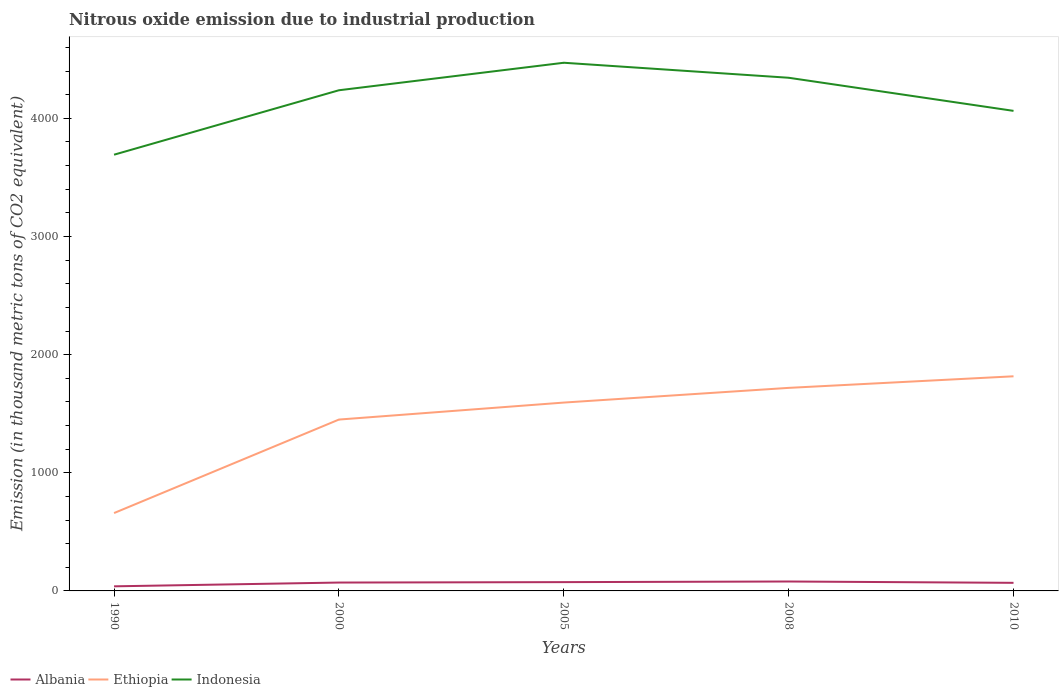Does the line corresponding to Indonesia intersect with the line corresponding to Ethiopia?
Offer a very short reply. No. Is the number of lines equal to the number of legend labels?
Offer a very short reply. Yes. Across all years, what is the maximum amount of nitrous oxide emitted in Albania?
Offer a terse response. 38.9. What is the total amount of nitrous oxide emitted in Albania in the graph?
Provide a short and direct response. -40.9. What is the difference between the highest and the second highest amount of nitrous oxide emitted in Albania?
Keep it short and to the point. 40.9. What is the difference between the highest and the lowest amount of nitrous oxide emitted in Ethiopia?
Your answer should be compact. 4. How many lines are there?
Provide a short and direct response. 3. Are the values on the major ticks of Y-axis written in scientific E-notation?
Your response must be concise. No. Where does the legend appear in the graph?
Your answer should be compact. Bottom left. How are the legend labels stacked?
Give a very brief answer. Horizontal. What is the title of the graph?
Offer a very short reply. Nitrous oxide emission due to industrial production. Does "Hong Kong" appear as one of the legend labels in the graph?
Offer a very short reply. No. What is the label or title of the X-axis?
Make the answer very short. Years. What is the label or title of the Y-axis?
Offer a terse response. Emission (in thousand metric tons of CO2 equivalent). What is the Emission (in thousand metric tons of CO2 equivalent) in Albania in 1990?
Give a very brief answer. 38.9. What is the Emission (in thousand metric tons of CO2 equivalent) of Ethiopia in 1990?
Keep it short and to the point. 659.1. What is the Emission (in thousand metric tons of CO2 equivalent) in Indonesia in 1990?
Your answer should be very brief. 3692.4. What is the Emission (in thousand metric tons of CO2 equivalent) in Albania in 2000?
Your answer should be very brief. 70.9. What is the Emission (in thousand metric tons of CO2 equivalent) in Ethiopia in 2000?
Give a very brief answer. 1450.5. What is the Emission (in thousand metric tons of CO2 equivalent) of Indonesia in 2000?
Offer a very short reply. 4237.9. What is the Emission (in thousand metric tons of CO2 equivalent) in Albania in 2005?
Your response must be concise. 74.5. What is the Emission (in thousand metric tons of CO2 equivalent) of Ethiopia in 2005?
Provide a short and direct response. 1594.3. What is the Emission (in thousand metric tons of CO2 equivalent) of Indonesia in 2005?
Offer a very short reply. 4470.7. What is the Emission (in thousand metric tons of CO2 equivalent) in Albania in 2008?
Your response must be concise. 79.8. What is the Emission (in thousand metric tons of CO2 equivalent) in Ethiopia in 2008?
Give a very brief answer. 1718.7. What is the Emission (in thousand metric tons of CO2 equivalent) in Indonesia in 2008?
Provide a short and direct response. 4343.7. What is the Emission (in thousand metric tons of CO2 equivalent) in Albania in 2010?
Your answer should be compact. 68.5. What is the Emission (in thousand metric tons of CO2 equivalent) in Ethiopia in 2010?
Keep it short and to the point. 1816.7. What is the Emission (in thousand metric tons of CO2 equivalent) of Indonesia in 2010?
Provide a succinct answer. 4063.4. Across all years, what is the maximum Emission (in thousand metric tons of CO2 equivalent) in Albania?
Your answer should be very brief. 79.8. Across all years, what is the maximum Emission (in thousand metric tons of CO2 equivalent) of Ethiopia?
Give a very brief answer. 1816.7. Across all years, what is the maximum Emission (in thousand metric tons of CO2 equivalent) in Indonesia?
Offer a terse response. 4470.7. Across all years, what is the minimum Emission (in thousand metric tons of CO2 equivalent) in Albania?
Your answer should be very brief. 38.9. Across all years, what is the minimum Emission (in thousand metric tons of CO2 equivalent) of Ethiopia?
Your answer should be very brief. 659.1. Across all years, what is the minimum Emission (in thousand metric tons of CO2 equivalent) in Indonesia?
Your answer should be compact. 3692.4. What is the total Emission (in thousand metric tons of CO2 equivalent) of Albania in the graph?
Offer a terse response. 332.6. What is the total Emission (in thousand metric tons of CO2 equivalent) of Ethiopia in the graph?
Keep it short and to the point. 7239.3. What is the total Emission (in thousand metric tons of CO2 equivalent) of Indonesia in the graph?
Keep it short and to the point. 2.08e+04. What is the difference between the Emission (in thousand metric tons of CO2 equivalent) of Albania in 1990 and that in 2000?
Make the answer very short. -32. What is the difference between the Emission (in thousand metric tons of CO2 equivalent) of Ethiopia in 1990 and that in 2000?
Ensure brevity in your answer.  -791.4. What is the difference between the Emission (in thousand metric tons of CO2 equivalent) in Indonesia in 1990 and that in 2000?
Offer a very short reply. -545.5. What is the difference between the Emission (in thousand metric tons of CO2 equivalent) of Albania in 1990 and that in 2005?
Provide a short and direct response. -35.6. What is the difference between the Emission (in thousand metric tons of CO2 equivalent) of Ethiopia in 1990 and that in 2005?
Make the answer very short. -935.2. What is the difference between the Emission (in thousand metric tons of CO2 equivalent) in Indonesia in 1990 and that in 2005?
Offer a very short reply. -778.3. What is the difference between the Emission (in thousand metric tons of CO2 equivalent) in Albania in 1990 and that in 2008?
Provide a succinct answer. -40.9. What is the difference between the Emission (in thousand metric tons of CO2 equivalent) of Ethiopia in 1990 and that in 2008?
Give a very brief answer. -1059.6. What is the difference between the Emission (in thousand metric tons of CO2 equivalent) of Indonesia in 1990 and that in 2008?
Ensure brevity in your answer.  -651.3. What is the difference between the Emission (in thousand metric tons of CO2 equivalent) of Albania in 1990 and that in 2010?
Provide a succinct answer. -29.6. What is the difference between the Emission (in thousand metric tons of CO2 equivalent) of Ethiopia in 1990 and that in 2010?
Give a very brief answer. -1157.6. What is the difference between the Emission (in thousand metric tons of CO2 equivalent) of Indonesia in 1990 and that in 2010?
Keep it short and to the point. -371. What is the difference between the Emission (in thousand metric tons of CO2 equivalent) of Albania in 2000 and that in 2005?
Provide a short and direct response. -3.6. What is the difference between the Emission (in thousand metric tons of CO2 equivalent) of Ethiopia in 2000 and that in 2005?
Give a very brief answer. -143.8. What is the difference between the Emission (in thousand metric tons of CO2 equivalent) in Indonesia in 2000 and that in 2005?
Provide a succinct answer. -232.8. What is the difference between the Emission (in thousand metric tons of CO2 equivalent) of Albania in 2000 and that in 2008?
Your answer should be compact. -8.9. What is the difference between the Emission (in thousand metric tons of CO2 equivalent) in Ethiopia in 2000 and that in 2008?
Ensure brevity in your answer.  -268.2. What is the difference between the Emission (in thousand metric tons of CO2 equivalent) of Indonesia in 2000 and that in 2008?
Offer a very short reply. -105.8. What is the difference between the Emission (in thousand metric tons of CO2 equivalent) in Ethiopia in 2000 and that in 2010?
Offer a terse response. -366.2. What is the difference between the Emission (in thousand metric tons of CO2 equivalent) of Indonesia in 2000 and that in 2010?
Give a very brief answer. 174.5. What is the difference between the Emission (in thousand metric tons of CO2 equivalent) in Albania in 2005 and that in 2008?
Your answer should be very brief. -5.3. What is the difference between the Emission (in thousand metric tons of CO2 equivalent) of Ethiopia in 2005 and that in 2008?
Keep it short and to the point. -124.4. What is the difference between the Emission (in thousand metric tons of CO2 equivalent) of Indonesia in 2005 and that in 2008?
Ensure brevity in your answer.  127. What is the difference between the Emission (in thousand metric tons of CO2 equivalent) of Albania in 2005 and that in 2010?
Provide a short and direct response. 6. What is the difference between the Emission (in thousand metric tons of CO2 equivalent) of Ethiopia in 2005 and that in 2010?
Offer a terse response. -222.4. What is the difference between the Emission (in thousand metric tons of CO2 equivalent) of Indonesia in 2005 and that in 2010?
Keep it short and to the point. 407.3. What is the difference between the Emission (in thousand metric tons of CO2 equivalent) of Albania in 2008 and that in 2010?
Offer a terse response. 11.3. What is the difference between the Emission (in thousand metric tons of CO2 equivalent) in Ethiopia in 2008 and that in 2010?
Keep it short and to the point. -98. What is the difference between the Emission (in thousand metric tons of CO2 equivalent) of Indonesia in 2008 and that in 2010?
Provide a succinct answer. 280.3. What is the difference between the Emission (in thousand metric tons of CO2 equivalent) in Albania in 1990 and the Emission (in thousand metric tons of CO2 equivalent) in Ethiopia in 2000?
Your response must be concise. -1411.6. What is the difference between the Emission (in thousand metric tons of CO2 equivalent) in Albania in 1990 and the Emission (in thousand metric tons of CO2 equivalent) in Indonesia in 2000?
Your answer should be compact. -4199. What is the difference between the Emission (in thousand metric tons of CO2 equivalent) in Ethiopia in 1990 and the Emission (in thousand metric tons of CO2 equivalent) in Indonesia in 2000?
Provide a succinct answer. -3578.8. What is the difference between the Emission (in thousand metric tons of CO2 equivalent) of Albania in 1990 and the Emission (in thousand metric tons of CO2 equivalent) of Ethiopia in 2005?
Offer a terse response. -1555.4. What is the difference between the Emission (in thousand metric tons of CO2 equivalent) in Albania in 1990 and the Emission (in thousand metric tons of CO2 equivalent) in Indonesia in 2005?
Make the answer very short. -4431.8. What is the difference between the Emission (in thousand metric tons of CO2 equivalent) of Ethiopia in 1990 and the Emission (in thousand metric tons of CO2 equivalent) of Indonesia in 2005?
Your answer should be compact. -3811.6. What is the difference between the Emission (in thousand metric tons of CO2 equivalent) in Albania in 1990 and the Emission (in thousand metric tons of CO2 equivalent) in Ethiopia in 2008?
Provide a short and direct response. -1679.8. What is the difference between the Emission (in thousand metric tons of CO2 equivalent) in Albania in 1990 and the Emission (in thousand metric tons of CO2 equivalent) in Indonesia in 2008?
Provide a succinct answer. -4304.8. What is the difference between the Emission (in thousand metric tons of CO2 equivalent) of Ethiopia in 1990 and the Emission (in thousand metric tons of CO2 equivalent) of Indonesia in 2008?
Ensure brevity in your answer.  -3684.6. What is the difference between the Emission (in thousand metric tons of CO2 equivalent) of Albania in 1990 and the Emission (in thousand metric tons of CO2 equivalent) of Ethiopia in 2010?
Your answer should be very brief. -1777.8. What is the difference between the Emission (in thousand metric tons of CO2 equivalent) of Albania in 1990 and the Emission (in thousand metric tons of CO2 equivalent) of Indonesia in 2010?
Provide a succinct answer. -4024.5. What is the difference between the Emission (in thousand metric tons of CO2 equivalent) in Ethiopia in 1990 and the Emission (in thousand metric tons of CO2 equivalent) in Indonesia in 2010?
Make the answer very short. -3404.3. What is the difference between the Emission (in thousand metric tons of CO2 equivalent) in Albania in 2000 and the Emission (in thousand metric tons of CO2 equivalent) in Ethiopia in 2005?
Provide a short and direct response. -1523.4. What is the difference between the Emission (in thousand metric tons of CO2 equivalent) in Albania in 2000 and the Emission (in thousand metric tons of CO2 equivalent) in Indonesia in 2005?
Ensure brevity in your answer.  -4399.8. What is the difference between the Emission (in thousand metric tons of CO2 equivalent) in Ethiopia in 2000 and the Emission (in thousand metric tons of CO2 equivalent) in Indonesia in 2005?
Your answer should be compact. -3020.2. What is the difference between the Emission (in thousand metric tons of CO2 equivalent) in Albania in 2000 and the Emission (in thousand metric tons of CO2 equivalent) in Ethiopia in 2008?
Offer a terse response. -1647.8. What is the difference between the Emission (in thousand metric tons of CO2 equivalent) in Albania in 2000 and the Emission (in thousand metric tons of CO2 equivalent) in Indonesia in 2008?
Ensure brevity in your answer.  -4272.8. What is the difference between the Emission (in thousand metric tons of CO2 equivalent) in Ethiopia in 2000 and the Emission (in thousand metric tons of CO2 equivalent) in Indonesia in 2008?
Your response must be concise. -2893.2. What is the difference between the Emission (in thousand metric tons of CO2 equivalent) of Albania in 2000 and the Emission (in thousand metric tons of CO2 equivalent) of Ethiopia in 2010?
Your answer should be compact. -1745.8. What is the difference between the Emission (in thousand metric tons of CO2 equivalent) in Albania in 2000 and the Emission (in thousand metric tons of CO2 equivalent) in Indonesia in 2010?
Your response must be concise. -3992.5. What is the difference between the Emission (in thousand metric tons of CO2 equivalent) in Ethiopia in 2000 and the Emission (in thousand metric tons of CO2 equivalent) in Indonesia in 2010?
Ensure brevity in your answer.  -2612.9. What is the difference between the Emission (in thousand metric tons of CO2 equivalent) of Albania in 2005 and the Emission (in thousand metric tons of CO2 equivalent) of Ethiopia in 2008?
Give a very brief answer. -1644.2. What is the difference between the Emission (in thousand metric tons of CO2 equivalent) in Albania in 2005 and the Emission (in thousand metric tons of CO2 equivalent) in Indonesia in 2008?
Give a very brief answer. -4269.2. What is the difference between the Emission (in thousand metric tons of CO2 equivalent) of Ethiopia in 2005 and the Emission (in thousand metric tons of CO2 equivalent) of Indonesia in 2008?
Offer a very short reply. -2749.4. What is the difference between the Emission (in thousand metric tons of CO2 equivalent) of Albania in 2005 and the Emission (in thousand metric tons of CO2 equivalent) of Ethiopia in 2010?
Provide a short and direct response. -1742.2. What is the difference between the Emission (in thousand metric tons of CO2 equivalent) in Albania in 2005 and the Emission (in thousand metric tons of CO2 equivalent) in Indonesia in 2010?
Offer a terse response. -3988.9. What is the difference between the Emission (in thousand metric tons of CO2 equivalent) in Ethiopia in 2005 and the Emission (in thousand metric tons of CO2 equivalent) in Indonesia in 2010?
Provide a succinct answer. -2469.1. What is the difference between the Emission (in thousand metric tons of CO2 equivalent) of Albania in 2008 and the Emission (in thousand metric tons of CO2 equivalent) of Ethiopia in 2010?
Ensure brevity in your answer.  -1736.9. What is the difference between the Emission (in thousand metric tons of CO2 equivalent) of Albania in 2008 and the Emission (in thousand metric tons of CO2 equivalent) of Indonesia in 2010?
Your answer should be compact. -3983.6. What is the difference between the Emission (in thousand metric tons of CO2 equivalent) in Ethiopia in 2008 and the Emission (in thousand metric tons of CO2 equivalent) in Indonesia in 2010?
Keep it short and to the point. -2344.7. What is the average Emission (in thousand metric tons of CO2 equivalent) in Albania per year?
Your answer should be very brief. 66.52. What is the average Emission (in thousand metric tons of CO2 equivalent) of Ethiopia per year?
Provide a short and direct response. 1447.86. What is the average Emission (in thousand metric tons of CO2 equivalent) in Indonesia per year?
Your answer should be very brief. 4161.62. In the year 1990, what is the difference between the Emission (in thousand metric tons of CO2 equivalent) of Albania and Emission (in thousand metric tons of CO2 equivalent) of Ethiopia?
Ensure brevity in your answer.  -620.2. In the year 1990, what is the difference between the Emission (in thousand metric tons of CO2 equivalent) in Albania and Emission (in thousand metric tons of CO2 equivalent) in Indonesia?
Make the answer very short. -3653.5. In the year 1990, what is the difference between the Emission (in thousand metric tons of CO2 equivalent) in Ethiopia and Emission (in thousand metric tons of CO2 equivalent) in Indonesia?
Ensure brevity in your answer.  -3033.3. In the year 2000, what is the difference between the Emission (in thousand metric tons of CO2 equivalent) in Albania and Emission (in thousand metric tons of CO2 equivalent) in Ethiopia?
Provide a short and direct response. -1379.6. In the year 2000, what is the difference between the Emission (in thousand metric tons of CO2 equivalent) of Albania and Emission (in thousand metric tons of CO2 equivalent) of Indonesia?
Offer a terse response. -4167. In the year 2000, what is the difference between the Emission (in thousand metric tons of CO2 equivalent) in Ethiopia and Emission (in thousand metric tons of CO2 equivalent) in Indonesia?
Provide a short and direct response. -2787.4. In the year 2005, what is the difference between the Emission (in thousand metric tons of CO2 equivalent) in Albania and Emission (in thousand metric tons of CO2 equivalent) in Ethiopia?
Your answer should be very brief. -1519.8. In the year 2005, what is the difference between the Emission (in thousand metric tons of CO2 equivalent) in Albania and Emission (in thousand metric tons of CO2 equivalent) in Indonesia?
Make the answer very short. -4396.2. In the year 2005, what is the difference between the Emission (in thousand metric tons of CO2 equivalent) of Ethiopia and Emission (in thousand metric tons of CO2 equivalent) of Indonesia?
Offer a very short reply. -2876.4. In the year 2008, what is the difference between the Emission (in thousand metric tons of CO2 equivalent) in Albania and Emission (in thousand metric tons of CO2 equivalent) in Ethiopia?
Keep it short and to the point. -1638.9. In the year 2008, what is the difference between the Emission (in thousand metric tons of CO2 equivalent) in Albania and Emission (in thousand metric tons of CO2 equivalent) in Indonesia?
Your answer should be very brief. -4263.9. In the year 2008, what is the difference between the Emission (in thousand metric tons of CO2 equivalent) in Ethiopia and Emission (in thousand metric tons of CO2 equivalent) in Indonesia?
Ensure brevity in your answer.  -2625. In the year 2010, what is the difference between the Emission (in thousand metric tons of CO2 equivalent) of Albania and Emission (in thousand metric tons of CO2 equivalent) of Ethiopia?
Give a very brief answer. -1748.2. In the year 2010, what is the difference between the Emission (in thousand metric tons of CO2 equivalent) of Albania and Emission (in thousand metric tons of CO2 equivalent) of Indonesia?
Keep it short and to the point. -3994.9. In the year 2010, what is the difference between the Emission (in thousand metric tons of CO2 equivalent) of Ethiopia and Emission (in thousand metric tons of CO2 equivalent) of Indonesia?
Give a very brief answer. -2246.7. What is the ratio of the Emission (in thousand metric tons of CO2 equivalent) in Albania in 1990 to that in 2000?
Provide a short and direct response. 0.55. What is the ratio of the Emission (in thousand metric tons of CO2 equivalent) in Ethiopia in 1990 to that in 2000?
Make the answer very short. 0.45. What is the ratio of the Emission (in thousand metric tons of CO2 equivalent) in Indonesia in 1990 to that in 2000?
Your response must be concise. 0.87. What is the ratio of the Emission (in thousand metric tons of CO2 equivalent) of Albania in 1990 to that in 2005?
Make the answer very short. 0.52. What is the ratio of the Emission (in thousand metric tons of CO2 equivalent) in Ethiopia in 1990 to that in 2005?
Your answer should be compact. 0.41. What is the ratio of the Emission (in thousand metric tons of CO2 equivalent) in Indonesia in 1990 to that in 2005?
Make the answer very short. 0.83. What is the ratio of the Emission (in thousand metric tons of CO2 equivalent) of Albania in 1990 to that in 2008?
Your answer should be compact. 0.49. What is the ratio of the Emission (in thousand metric tons of CO2 equivalent) in Ethiopia in 1990 to that in 2008?
Make the answer very short. 0.38. What is the ratio of the Emission (in thousand metric tons of CO2 equivalent) in Indonesia in 1990 to that in 2008?
Your answer should be very brief. 0.85. What is the ratio of the Emission (in thousand metric tons of CO2 equivalent) of Albania in 1990 to that in 2010?
Ensure brevity in your answer.  0.57. What is the ratio of the Emission (in thousand metric tons of CO2 equivalent) in Ethiopia in 1990 to that in 2010?
Your answer should be compact. 0.36. What is the ratio of the Emission (in thousand metric tons of CO2 equivalent) of Indonesia in 1990 to that in 2010?
Offer a terse response. 0.91. What is the ratio of the Emission (in thousand metric tons of CO2 equivalent) of Albania in 2000 to that in 2005?
Your answer should be compact. 0.95. What is the ratio of the Emission (in thousand metric tons of CO2 equivalent) of Ethiopia in 2000 to that in 2005?
Provide a short and direct response. 0.91. What is the ratio of the Emission (in thousand metric tons of CO2 equivalent) of Indonesia in 2000 to that in 2005?
Keep it short and to the point. 0.95. What is the ratio of the Emission (in thousand metric tons of CO2 equivalent) of Albania in 2000 to that in 2008?
Ensure brevity in your answer.  0.89. What is the ratio of the Emission (in thousand metric tons of CO2 equivalent) in Ethiopia in 2000 to that in 2008?
Your answer should be compact. 0.84. What is the ratio of the Emission (in thousand metric tons of CO2 equivalent) in Indonesia in 2000 to that in 2008?
Give a very brief answer. 0.98. What is the ratio of the Emission (in thousand metric tons of CO2 equivalent) of Albania in 2000 to that in 2010?
Ensure brevity in your answer.  1.03. What is the ratio of the Emission (in thousand metric tons of CO2 equivalent) in Ethiopia in 2000 to that in 2010?
Your answer should be compact. 0.8. What is the ratio of the Emission (in thousand metric tons of CO2 equivalent) of Indonesia in 2000 to that in 2010?
Provide a succinct answer. 1.04. What is the ratio of the Emission (in thousand metric tons of CO2 equivalent) in Albania in 2005 to that in 2008?
Your answer should be compact. 0.93. What is the ratio of the Emission (in thousand metric tons of CO2 equivalent) of Ethiopia in 2005 to that in 2008?
Give a very brief answer. 0.93. What is the ratio of the Emission (in thousand metric tons of CO2 equivalent) of Indonesia in 2005 to that in 2008?
Provide a short and direct response. 1.03. What is the ratio of the Emission (in thousand metric tons of CO2 equivalent) in Albania in 2005 to that in 2010?
Give a very brief answer. 1.09. What is the ratio of the Emission (in thousand metric tons of CO2 equivalent) in Ethiopia in 2005 to that in 2010?
Make the answer very short. 0.88. What is the ratio of the Emission (in thousand metric tons of CO2 equivalent) in Indonesia in 2005 to that in 2010?
Your answer should be compact. 1.1. What is the ratio of the Emission (in thousand metric tons of CO2 equivalent) of Albania in 2008 to that in 2010?
Provide a succinct answer. 1.17. What is the ratio of the Emission (in thousand metric tons of CO2 equivalent) in Ethiopia in 2008 to that in 2010?
Give a very brief answer. 0.95. What is the ratio of the Emission (in thousand metric tons of CO2 equivalent) of Indonesia in 2008 to that in 2010?
Give a very brief answer. 1.07. What is the difference between the highest and the second highest Emission (in thousand metric tons of CO2 equivalent) in Albania?
Provide a succinct answer. 5.3. What is the difference between the highest and the second highest Emission (in thousand metric tons of CO2 equivalent) in Indonesia?
Keep it short and to the point. 127. What is the difference between the highest and the lowest Emission (in thousand metric tons of CO2 equivalent) in Albania?
Provide a succinct answer. 40.9. What is the difference between the highest and the lowest Emission (in thousand metric tons of CO2 equivalent) of Ethiopia?
Offer a terse response. 1157.6. What is the difference between the highest and the lowest Emission (in thousand metric tons of CO2 equivalent) in Indonesia?
Offer a very short reply. 778.3. 